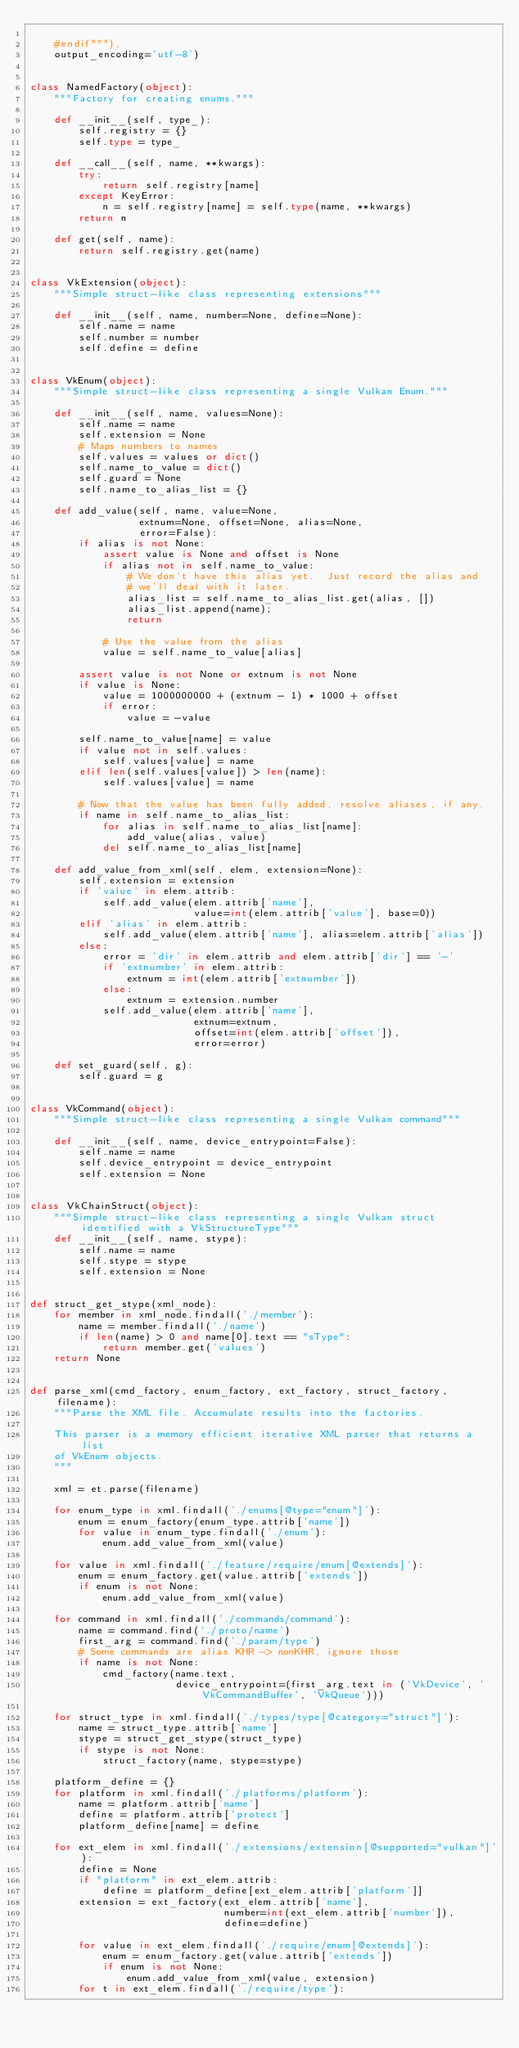Convert code to text. <code><loc_0><loc_0><loc_500><loc_500><_Python_>
    #endif"""),
    output_encoding='utf-8')


class NamedFactory(object):
    """Factory for creating enums."""

    def __init__(self, type_):
        self.registry = {}
        self.type = type_

    def __call__(self, name, **kwargs):
        try:
            return self.registry[name]
        except KeyError:
            n = self.registry[name] = self.type(name, **kwargs)
        return n

    def get(self, name):
        return self.registry.get(name)


class VkExtension(object):
    """Simple struct-like class representing extensions"""

    def __init__(self, name, number=None, define=None):
        self.name = name
        self.number = number
        self.define = define


class VkEnum(object):
    """Simple struct-like class representing a single Vulkan Enum."""

    def __init__(self, name, values=None):
        self.name = name
        self.extension = None
        # Maps numbers to names
        self.values = values or dict()
        self.name_to_value = dict()
        self.guard = None
        self.name_to_alias_list = {}

    def add_value(self, name, value=None,
                  extnum=None, offset=None, alias=None,
                  error=False):
        if alias is not None:
            assert value is None and offset is None
            if alias not in self.name_to_value:
                # We don't have this alias yet.  Just record the alias and
                # we'll deal with it later.
                alias_list = self.name_to_alias_list.get(alias, [])
                alias_list.append(name);
                return

            # Use the value from the alias
            value = self.name_to_value[alias]

        assert value is not None or extnum is not None
        if value is None:
            value = 1000000000 + (extnum - 1) * 1000 + offset
            if error:
                value = -value

        self.name_to_value[name] = value
        if value not in self.values:
            self.values[value] = name
        elif len(self.values[value]) > len(name):
            self.values[value] = name

        # Now that the value has been fully added, resolve aliases, if any.
        if name in self.name_to_alias_list:
            for alias in self.name_to_alias_list[name]:
                add_value(alias, value)
            del self.name_to_alias_list[name]

    def add_value_from_xml(self, elem, extension=None):
        self.extension = extension
        if 'value' in elem.attrib:
            self.add_value(elem.attrib['name'],
                           value=int(elem.attrib['value'], base=0))
        elif 'alias' in elem.attrib:
            self.add_value(elem.attrib['name'], alias=elem.attrib['alias'])
        else:
            error = 'dir' in elem.attrib and elem.attrib['dir'] == '-'
            if 'extnumber' in elem.attrib:
                extnum = int(elem.attrib['extnumber'])
            else:
                extnum = extension.number
            self.add_value(elem.attrib['name'],
                           extnum=extnum,
                           offset=int(elem.attrib['offset']),
                           error=error)

    def set_guard(self, g):
        self.guard = g


class VkCommand(object):
    """Simple struct-like class representing a single Vulkan command"""

    def __init__(self, name, device_entrypoint=False):
        self.name = name
        self.device_entrypoint = device_entrypoint
        self.extension = None


class VkChainStruct(object):
    """Simple struct-like class representing a single Vulkan struct identified with a VkStructureType"""
    def __init__(self, name, stype):
        self.name = name
        self.stype = stype
        self.extension = None


def struct_get_stype(xml_node):
    for member in xml_node.findall('./member'):
        name = member.findall('./name')
        if len(name) > 0 and name[0].text == "sType":
            return member.get('values')
    return None


def parse_xml(cmd_factory, enum_factory, ext_factory, struct_factory, filename):
    """Parse the XML file. Accumulate results into the factories.

    This parser is a memory efficient iterative XML parser that returns a list
    of VkEnum objects.
    """

    xml = et.parse(filename)

    for enum_type in xml.findall('./enums[@type="enum"]'):
        enum = enum_factory(enum_type.attrib['name'])
        for value in enum_type.findall('./enum'):
            enum.add_value_from_xml(value)

    for value in xml.findall('./feature/require/enum[@extends]'):
        enum = enum_factory.get(value.attrib['extends'])
        if enum is not None:
            enum.add_value_from_xml(value)

    for command in xml.findall('./commands/command'):
        name = command.find('./proto/name')
        first_arg = command.find('./param/type')
        # Some commands are alias KHR -> nonKHR, ignore those
        if name is not None:
            cmd_factory(name.text,
                        device_entrypoint=(first_arg.text in ('VkDevice', 'VkCommandBuffer', 'VkQueue')))

    for struct_type in xml.findall('./types/type[@category="struct"]'):
        name = struct_type.attrib['name']
        stype = struct_get_stype(struct_type)
        if stype is not None:
            struct_factory(name, stype=stype)

    platform_define = {}
    for platform in xml.findall('./platforms/platform'):
        name = platform.attrib['name']
        define = platform.attrib['protect']
        platform_define[name] = define

    for ext_elem in xml.findall('./extensions/extension[@supported="vulkan"]'):
        define = None
        if "platform" in ext_elem.attrib:
            define = platform_define[ext_elem.attrib['platform']]
        extension = ext_factory(ext_elem.attrib['name'],
                                number=int(ext_elem.attrib['number']),
                                define=define)

        for value in ext_elem.findall('./require/enum[@extends]'):
            enum = enum_factory.get(value.attrib['extends'])
            if enum is not None:
                enum.add_value_from_xml(value, extension)
        for t in ext_elem.findall('./require/type'):</code> 